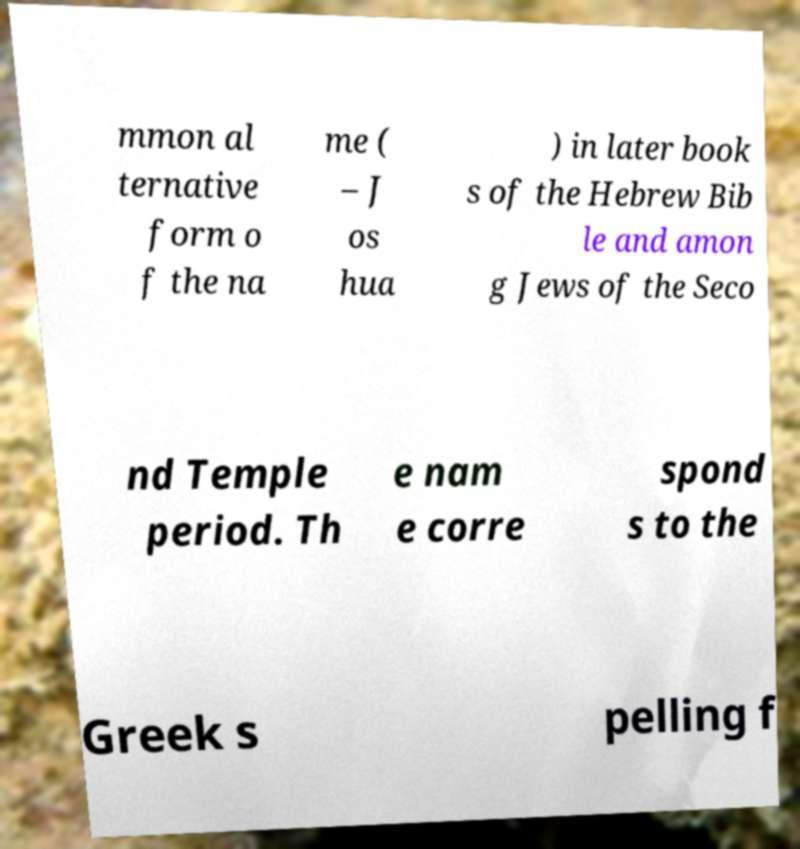What messages or text are displayed in this image? I need them in a readable, typed format. mmon al ternative form o f the na me ( – J os hua ) in later book s of the Hebrew Bib le and amon g Jews of the Seco nd Temple period. Th e nam e corre spond s to the Greek s pelling f 